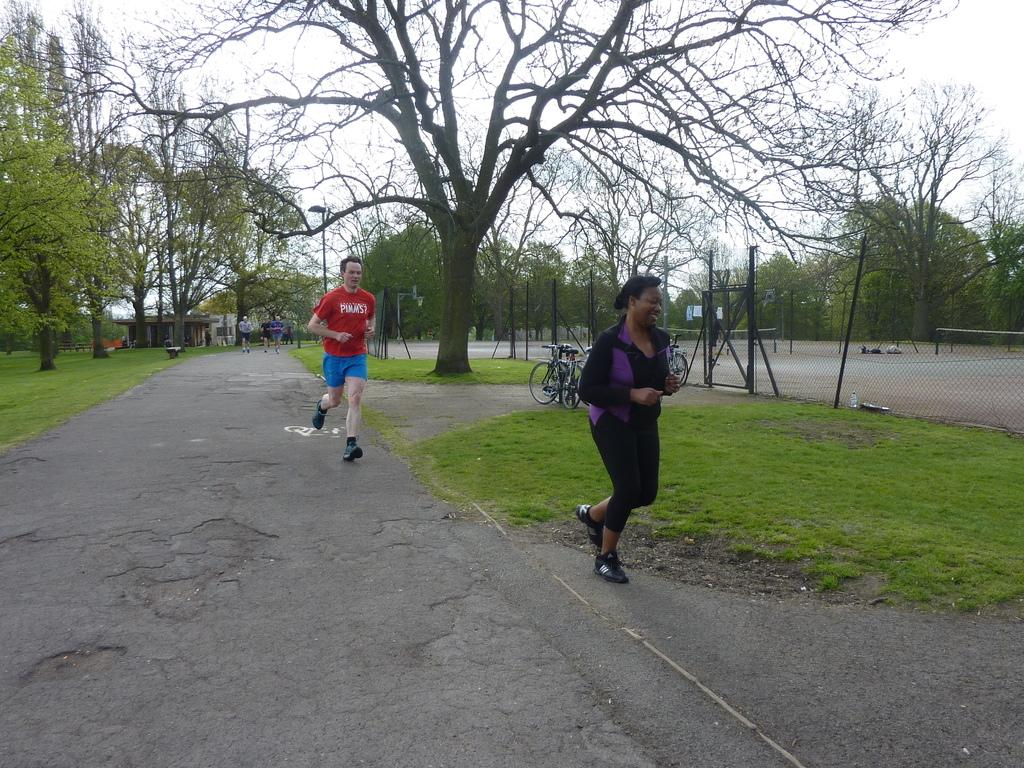What are the people in the image doing? The people in the image are running on the road. What can be seen beside the road in the image? There are trees beside the road in the image. What type of vegetation is visible in the image? There is grass visible in the image. What is surrounding the ground in the image? There is a fence around the ground in the image. What book is the person reading while running in the image? There is no person reading a book while running in the image; the people are focused on running. 